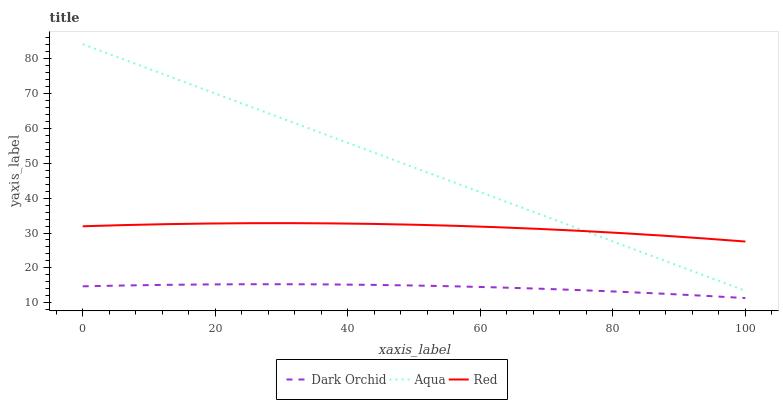Does Red have the minimum area under the curve?
Answer yes or no. No. Does Red have the maximum area under the curve?
Answer yes or no. No. Is Dark Orchid the smoothest?
Answer yes or no. No. Is Dark Orchid the roughest?
Answer yes or no. No. Does Red have the lowest value?
Answer yes or no. No. Does Red have the highest value?
Answer yes or no. No. Is Dark Orchid less than Red?
Answer yes or no. Yes. Is Aqua greater than Dark Orchid?
Answer yes or no. Yes. Does Dark Orchid intersect Red?
Answer yes or no. No. 